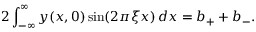Convert formula to latex. <formula><loc_0><loc_0><loc_500><loc_500>2 \int _ { - \infty } ^ { \infty } y ( x , 0 ) \sin ( 2 \pi \xi x ) \, d x = b _ { + } + b _ { - } .</formula> 